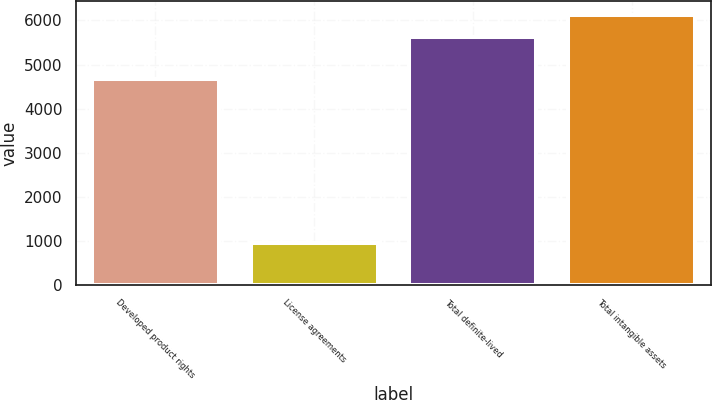<chart> <loc_0><loc_0><loc_500><loc_500><bar_chart><fcel>Developed product rights<fcel>License agreements<fcel>Total definite-lived<fcel>Total intangible assets<nl><fcel>4675<fcel>949<fcel>5624<fcel>6134<nl></chart> 